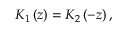Convert formula to latex. <formula><loc_0><loc_0><loc_500><loc_500>K _ { 1 } \left ( z \right ) = K _ { 2 } \left ( - z \right ) ,</formula> 